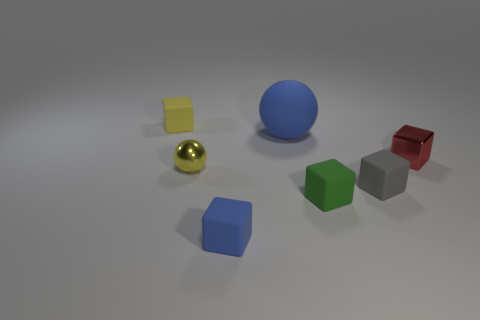How many rubber objects have the same color as the large matte sphere?
Provide a short and direct response. 1. Do the tiny yellow rubber thing and the large object have the same shape?
Your answer should be compact. No. Is there any other thing that is the same size as the blue matte sphere?
Make the answer very short. No. What size is the matte object that is the same shape as the yellow metallic object?
Give a very brief answer. Large. Is the number of small things that are in front of the big matte thing greater than the number of objects that are on the left side of the gray cube?
Give a very brief answer. No. Do the tiny blue block and the yellow thing that is right of the tiny yellow rubber cube have the same material?
Ensure brevity in your answer.  No. The rubber thing that is left of the green thing and in front of the tiny red shiny block is what color?
Provide a succinct answer. Blue. What shape is the small yellow thing behind the small red block?
Your answer should be very brief. Cube. How big is the blue object in front of the yellow object in front of the object to the right of the gray rubber object?
Give a very brief answer. Small. There is a yellow thing that is in front of the small red object; what number of blue balls are right of it?
Keep it short and to the point. 1. 